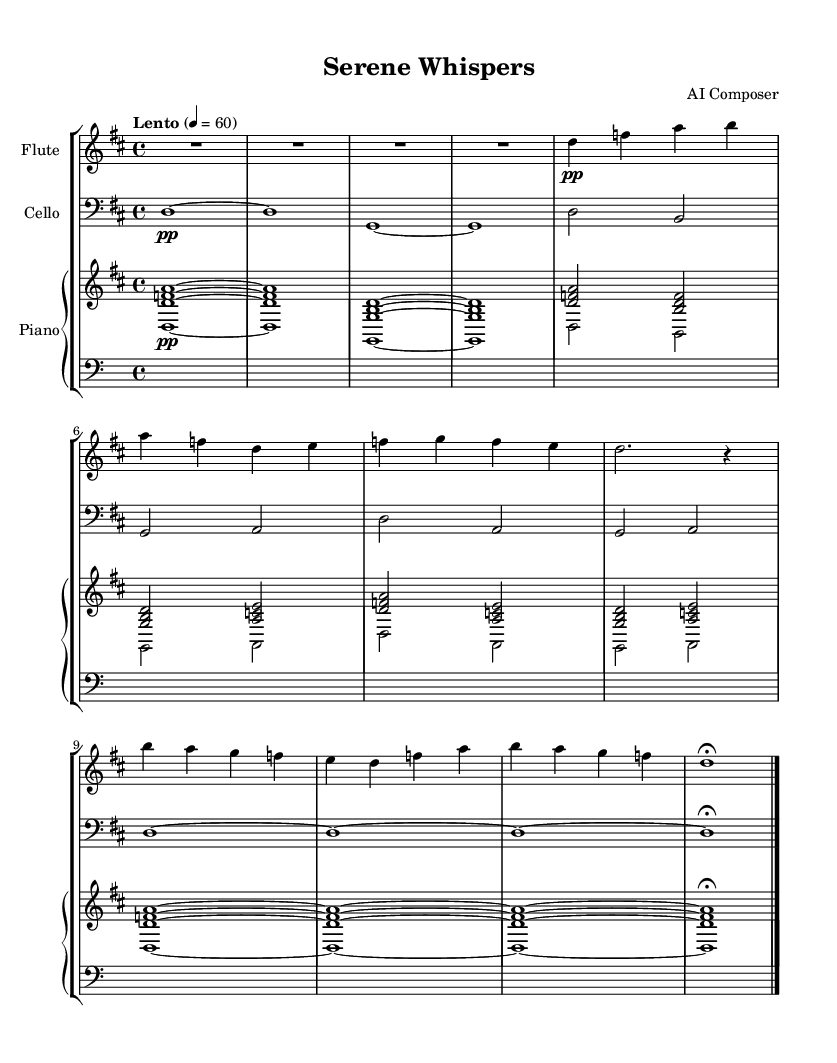What is the key signature of this music? The key signature is D major, which has two sharps (F# and C#). This can be identified by looking at the key signature at the beginning of the staff, which contains two sharp symbols.
Answer: D major What is the time signature of this music? The time signature is 4/4, indicated at the beginning of the score. This means there are four beats in each measure and the quarter note gets one beat.
Answer: 4/4 What is the tempo marking for this piece? The tempo marking indicates "Lento," meaning a slow pace. This is specified in the tempo indication at the beginning of the score, set to 60 beats per minute.
Answer: Lento How many measures are there in the score? There are a total of 12 measures in the score. This can be counted by observing the bar lines that separate each measure in the music.
Answer: 12 Which instruments are featured in this composition? The featured instruments are flute, cello, and piano. This information can be found in the staff labels at the start of each section that denote the specific instruments.
Answer: Flute, cello, piano What is the dynamic marking for the flute section in the first measure? The dynamic marking for the flute in the first measure is "pp," indicating "pianissimo," which means very soft. This is noted right above the flute notes in the first measure.
Answer: pp Which chord appears first in the piano part? The first chord in the piano part is the D minor chord, which consists of the notes D, F, and A. It is presented in the first measure of the upper staff of the piano.
Answer: D minor chord 